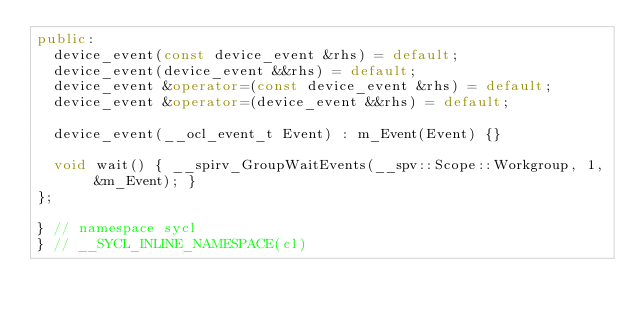<code> <loc_0><loc_0><loc_500><loc_500><_C++_>public:
  device_event(const device_event &rhs) = default;
  device_event(device_event &&rhs) = default;
  device_event &operator=(const device_event &rhs) = default;
  device_event &operator=(device_event &&rhs) = default;

  device_event(__ocl_event_t Event) : m_Event(Event) {}

  void wait() { __spirv_GroupWaitEvents(__spv::Scope::Workgroup, 1, &m_Event); }
};

} // namespace sycl
} // __SYCL_INLINE_NAMESPACE(cl)
</code> 